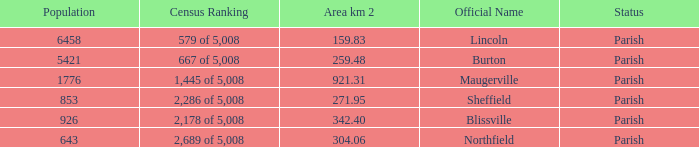What are the official name(s) of places with an area of 304.06 km2? Northfield. 